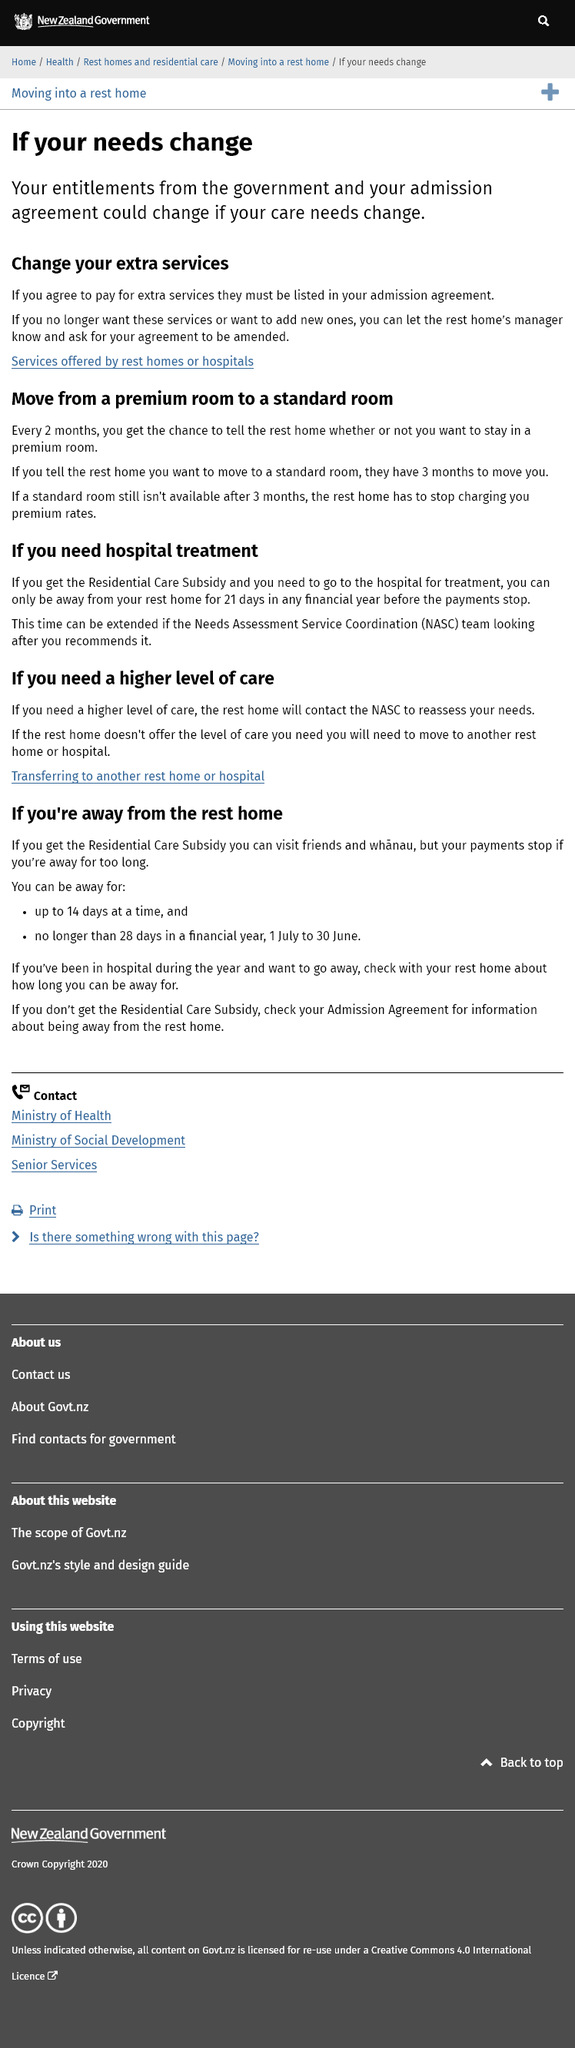List a handful of essential elements in this visual. It is possible to transition from a premium room to a standard room. If your needs change, your entitlements from the government and your admission agreement may change as well. Services for the elderly are provided by either rest homes or hospitals. 